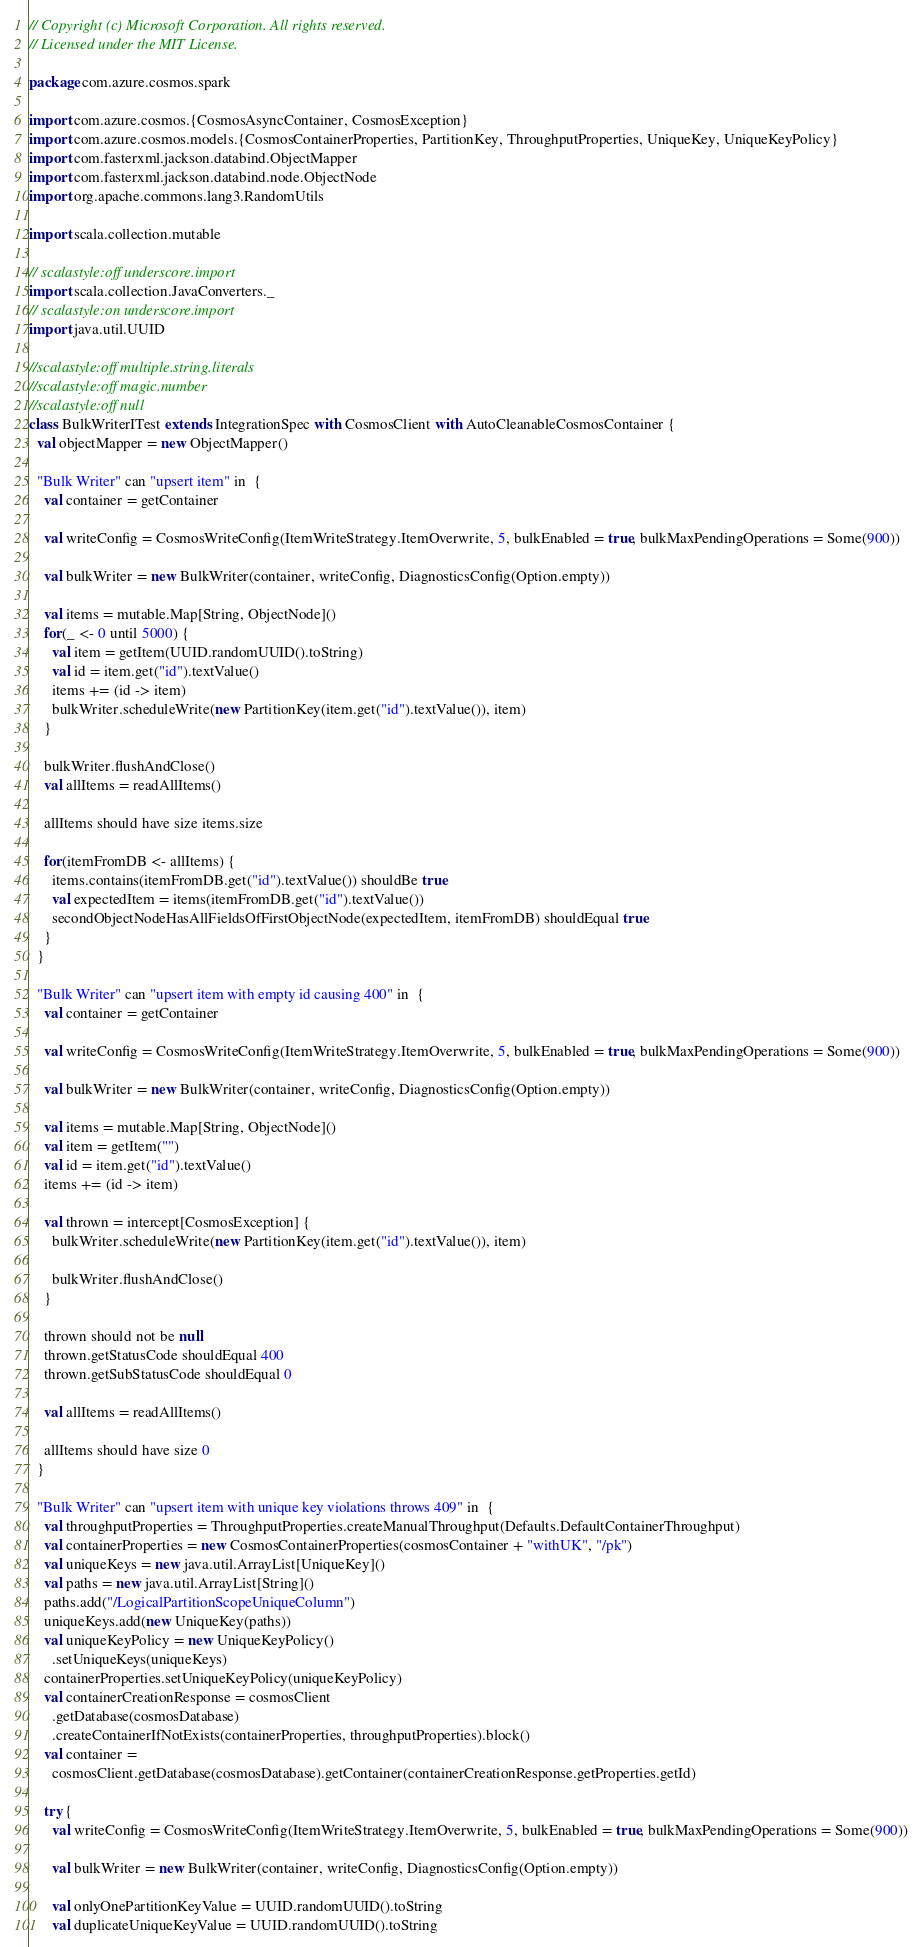<code> <loc_0><loc_0><loc_500><loc_500><_Scala_>// Copyright (c) Microsoft Corporation. All rights reserved.
// Licensed under the MIT License.

package com.azure.cosmos.spark

import com.azure.cosmos.{CosmosAsyncContainer, CosmosException}
import com.azure.cosmos.models.{CosmosContainerProperties, PartitionKey, ThroughputProperties, UniqueKey, UniqueKeyPolicy}
import com.fasterxml.jackson.databind.ObjectMapper
import com.fasterxml.jackson.databind.node.ObjectNode
import org.apache.commons.lang3.RandomUtils

import scala.collection.mutable

// scalastyle:off underscore.import
import scala.collection.JavaConverters._
// scalastyle:on underscore.import
import java.util.UUID

//scalastyle:off multiple.string.literals
//scalastyle:off magic.number
//scalastyle:off null
class BulkWriterITest extends IntegrationSpec with CosmosClient with AutoCleanableCosmosContainer {
  val objectMapper = new ObjectMapper()

  "Bulk Writer" can "upsert item" in  {
    val container = getContainer

    val writeConfig = CosmosWriteConfig(ItemWriteStrategy.ItemOverwrite, 5, bulkEnabled = true, bulkMaxPendingOperations = Some(900))

    val bulkWriter = new BulkWriter(container, writeConfig, DiagnosticsConfig(Option.empty))

    val items = mutable.Map[String, ObjectNode]()
    for(_ <- 0 until 5000) {
      val item = getItem(UUID.randomUUID().toString)
      val id = item.get("id").textValue()
      items += (id -> item)
      bulkWriter.scheduleWrite(new PartitionKey(item.get("id").textValue()), item)
    }

    bulkWriter.flushAndClose()
    val allItems = readAllItems()

    allItems should have size items.size

    for(itemFromDB <- allItems) {
      items.contains(itemFromDB.get("id").textValue()) shouldBe true
      val expectedItem = items(itemFromDB.get("id").textValue())
      secondObjectNodeHasAllFieldsOfFirstObjectNode(expectedItem, itemFromDB) shouldEqual true
    }
  }

  "Bulk Writer" can "upsert item with empty id causing 400" in  {
    val container = getContainer

    val writeConfig = CosmosWriteConfig(ItemWriteStrategy.ItemOverwrite, 5, bulkEnabled = true, bulkMaxPendingOperations = Some(900))

    val bulkWriter = new BulkWriter(container, writeConfig, DiagnosticsConfig(Option.empty))

    val items = mutable.Map[String, ObjectNode]()
    val item = getItem("")
    val id = item.get("id").textValue()
    items += (id -> item)

    val thrown = intercept[CosmosException] {
      bulkWriter.scheduleWrite(new PartitionKey(item.get("id").textValue()), item)

      bulkWriter.flushAndClose()
    }

    thrown should not be null
    thrown.getStatusCode shouldEqual 400
    thrown.getSubStatusCode shouldEqual 0

    val allItems = readAllItems()

    allItems should have size 0
  }

  "Bulk Writer" can "upsert item with unique key violations throws 409" in  {
    val throughputProperties = ThroughputProperties.createManualThroughput(Defaults.DefaultContainerThroughput)
    val containerProperties = new CosmosContainerProperties(cosmosContainer + "withUK", "/pk")
    val uniqueKeys = new java.util.ArrayList[UniqueKey]()
    val paths = new java.util.ArrayList[String]()
    paths.add("/LogicalPartitionScopeUniqueColumn")
    uniqueKeys.add(new UniqueKey(paths))
    val uniqueKeyPolicy = new UniqueKeyPolicy()
      .setUniqueKeys(uniqueKeys)
    containerProperties.setUniqueKeyPolicy(uniqueKeyPolicy)
    val containerCreationResponse = cosmosClient
      .getDatabase(cosmosDatabase)
      .createContainerIfNotExists(containerProperties, throughputProperties).block()
    val container =
      cosmosClient.getDatabase(cosmosDatabase).getContainer(containerCreationResponse.getProperties.getId)

    try {
      val writeConfig = CosmosWriteConfig(ItemWriteStrategy.ItemOverwrite, 5, bulkEnabled = true, bulkMaxPendingOperations = Some(900))

      val bulkWriter = new BulkWriter(container, writeConfig, DiagnosticsConfig(Option.empty))

      val onlyOnePartitionKeyValue = UUID.randomUUID().toString
      val duplicateUniqueKeyValue = UUID.randomUUID().toString</code> 